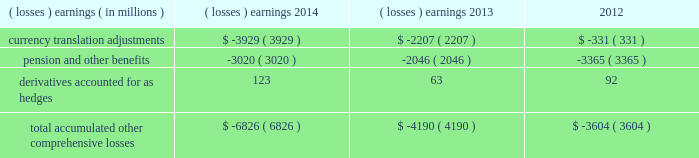Note 17 .
Accumulated other comprehensive losses : pmi's accumulated other comprehensive losses , net of taxes , consisted of the following: .
Reclassifications from other comprehensive earnings the movements in accumulated other comprehensive losses and the related tax impact , for each of the components above , that are due to current period activity and reclassifications to the income statement are shown on the consolidated statements of comprehensive earnings for the years ended december 31 , 2014 , 2013 , and 2012 .
The movement in currency translation adjustments for the year ended december 31 , 2013 , was also impacted by the purchase of the remaining shares of the mexican tobacco business .
In addition , $ 5 million and $ 12 million of net currency translation adjustment gains were transferred from other comprehensive earnings to marketing , administration and research costs in the consolidated statements of earnings for the years ended december 31 , 2014 and 2013 , respectively , upon liquidation of a subsidiary .
For additional information , see note 13 .
Benefit plans and note 15 .
Financial instruments for disclosures related to pmi's pension and other benefits and derivative financial instruments .
Note 18 .
Colombian investment and cooperation agreement : on june 19 , 2009 , pmi announced that it had signed an agreement with the republic of colombia , together with the departments of colombia and the capital district of bogota , to promote investment and cooperation with respect to the colombian tobacco market and to fight counterfeit and contraband tobacco products .
The investment and cooperation agreement provides $ 200 million in funding to the colombian governments over a 20-year period to address issues of mutual interest , such as combating the illegal cigarette trade , including the threat of counterfeit tobacco products , and increasing the quality and quantity of locally grown tobacco .
As a result of the investment and cooperation agreement , pmi recorded a pre-tax charge of $ 135 million in the operating results of the latin america & canada segment during the second quarter of 2009 .
At december 31 , 2014 and 2013 , pmi had $ 71 million and $ 74 million , respectively , of discounted liabilities associated with the colombian investment and cooperation agreement .
These discounted liabilities are primarily reflected in other long-term liabilities on the consolidated balance sheets and are expected to be paid through 2028 .
Note 19 .
Rbh legal settlement : on july 31 , 2008 , rothmans inc .
( "rothmans" ) announced the finalization of a cad 550 million settlement ( or approximately $ 540 million , based on the prevailing exchange rate at that time ) between itself and rothmans , benson & hedges inc .
( "rbh" ) , on the one hand , and the government of canada and all 10 provinces , on the other hand .
The settlement resolved the royal canadian mounted police's investigation relating to products exported from canada by rbh during the 1989-1996 period .
Rothmans' sole holding was a 60% ( 60 % ) interest in rbh .
The remaining 40% ( 40 % ) interest in rbh was owned by pmi. .
What is the percentage change in discounted liabilities from 2013 to 2014? 
Computations: ((71 - 74) / 74)
Answer: -0.04054. 